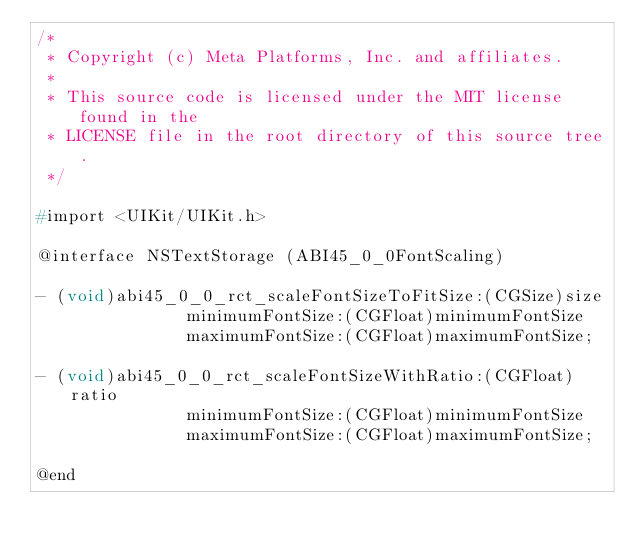Convert code to text. <code><loc_0><loc_0><loc_500><loc_500><_C_>/*
 * Copyright (c) Meta Platforms, Inc. and affiliates.
 *
 * This source code is licensed under the MIT license found in the
 * LICENSE file in the root directory of this source tree.
 */

#import <UIKit/UIKit.h>

@interface NSTextStorage (ABI45_0_0FontScaling)

- (void)abi45_0_0_rct_scaleFontSizeToFitSize:(CGSize)size
               minimumFontSize:(CGFloat)minimumFontSize
               maximumFontSize:(CGFloat)maximumFontSize;

- (void)abi45_0_0_rct_scaleFontSizeWithRatio:(CGFloat)ratio
               minimumFontSize:(CGFloat)minimumFontSize
               maximumFontSize:(CGFloat)maximumFontSize;

@end
</code> 